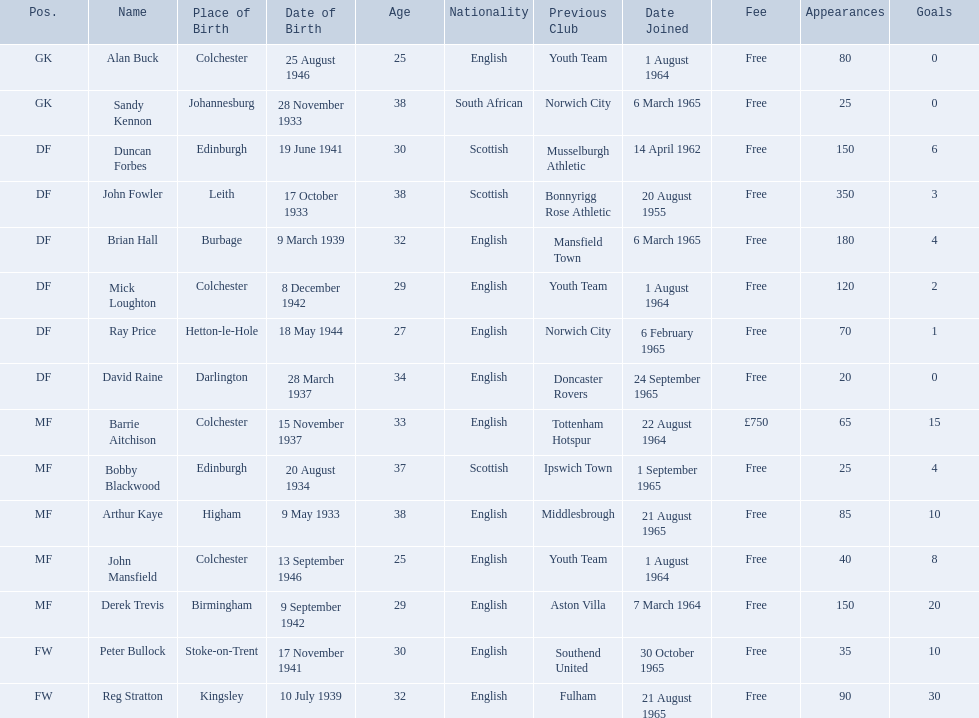When did alan buck join the colchester united f.c. in 1965-66? 1 August 1964. When did the last player to join? Peter Bullock. What date did the first player join? 20 August 1955. 